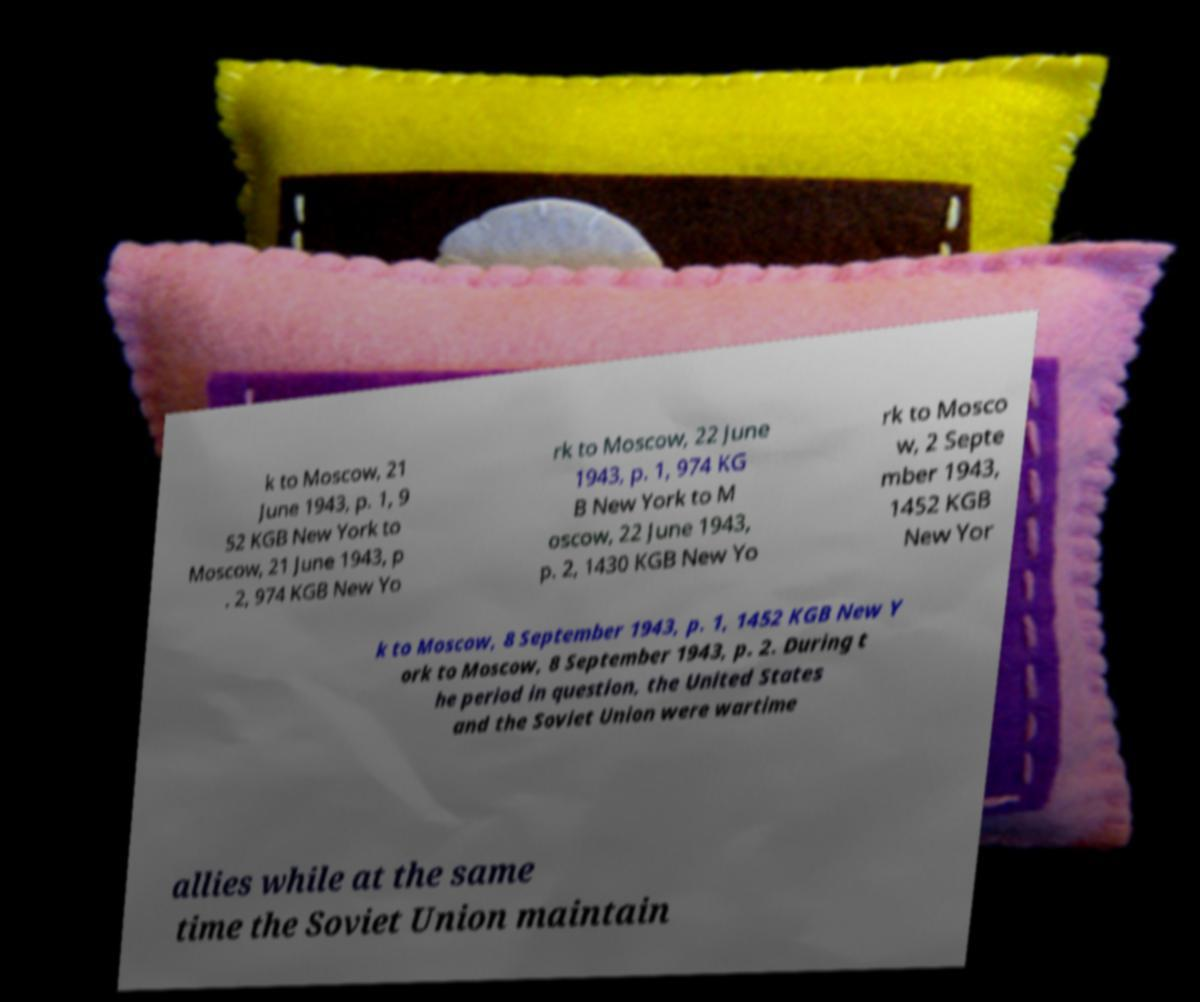Can you read and provide the text displayed in the image?This photo seems to have some interesting text. Can you extract and type it out for me? k to Moscow, 21 June 1943, p. 1, 9 52 KGB New York to Moscow, 21 June 1943, p . 2, 974 KGB New Yo rk to Moscow, 22 June 1943, p. 1, 974 KG B New York to M oscow, 22 June 1943, p. 2, 1430 KGB New Yo rk to Mosco w, 2 Septe mber 1943, 1452 KGB New Yor k to Moscow, 8 September 1943, p. 1, 1452 KGB New Y ork to Moscow, 8 September 1943, p. 2. During t he period in question, the United States and the Soviet Union were wartime allies while at the same time the Soviet Union maintain 